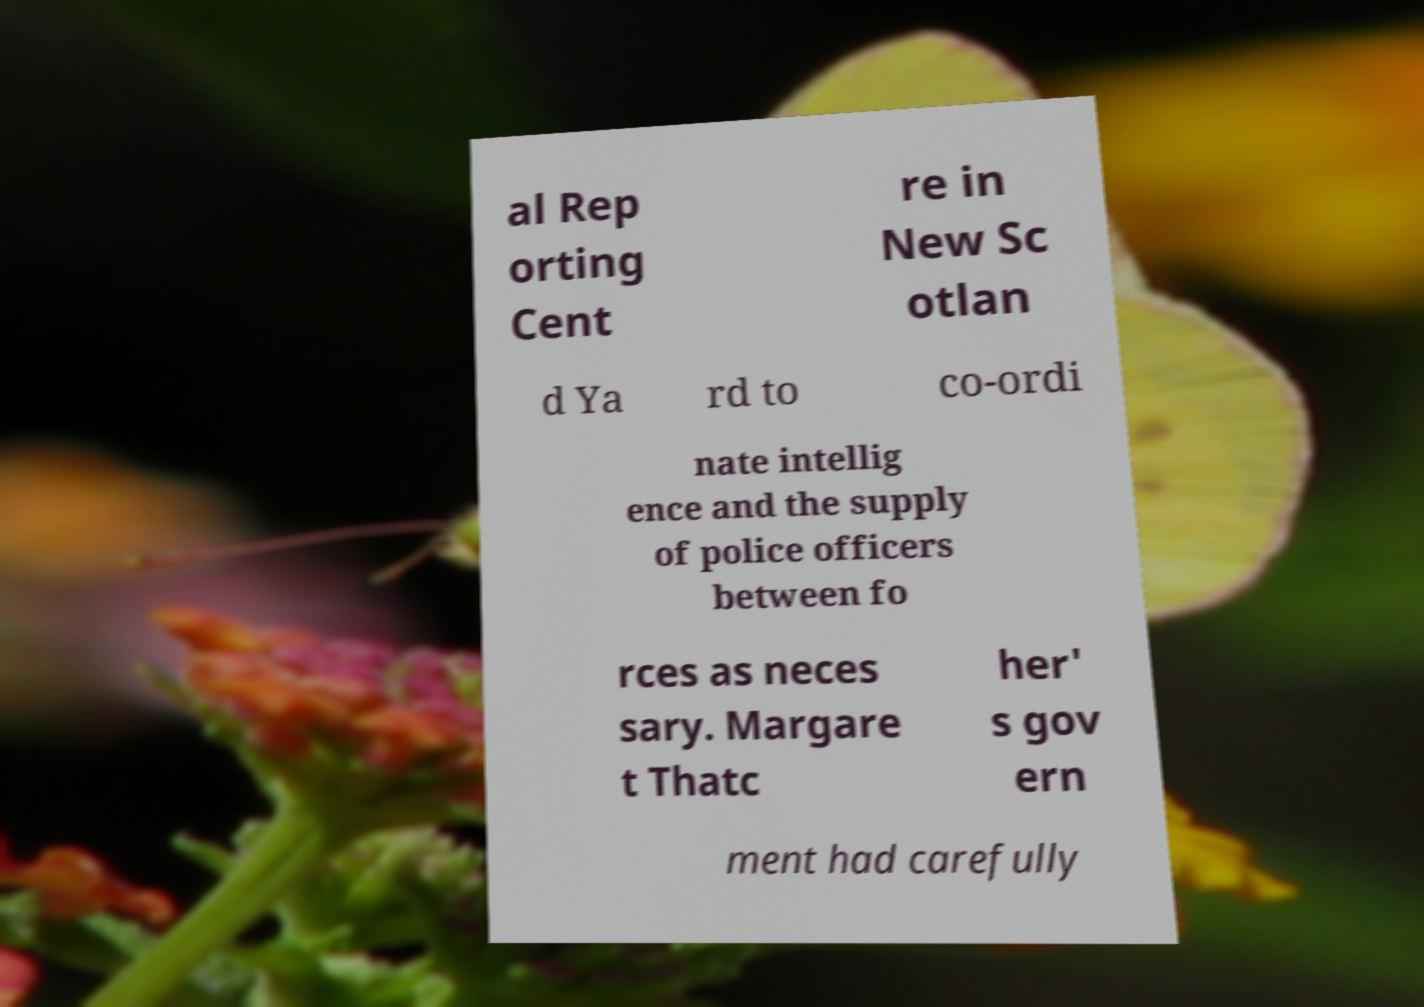Please identify and transcribe the text found in this image. al Rep orting Cent re in New Sc otlan d Ya rd to co-ordi nate intellig ence and the supply of police officers between fo rces as neces sary. Margare t Thatc her' s gov ern ment had carefully 